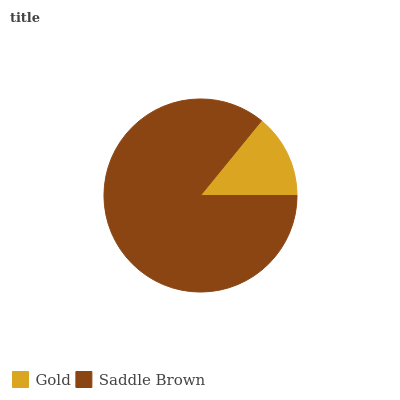Is Gold the minimum?
Answer yes or no. Yes. Is Saddle Brown the maximum?
Answer yes or no. Yes. Is Saddle Brown the minimum?
Answer yes or no. No. Is Saddle Brown greater than Gold?
Answer yes or no. Yes. Is Gold less than Saddle Brown?
Answer yes or no. Yes. Is Gold greater than Saddle Brown?
Answer yes or no. No. Is Saddle Brown less than Gold?
Answer yes or no. No. Is Saddle Brown the high median?
Answer yes or no. Yes. Is Gold the low median?
Answer yes or no. Yes. Is Gold the high median?
Answer yes or no. No. Is Saddle Brown the low median?
Answer yes or no. No. 